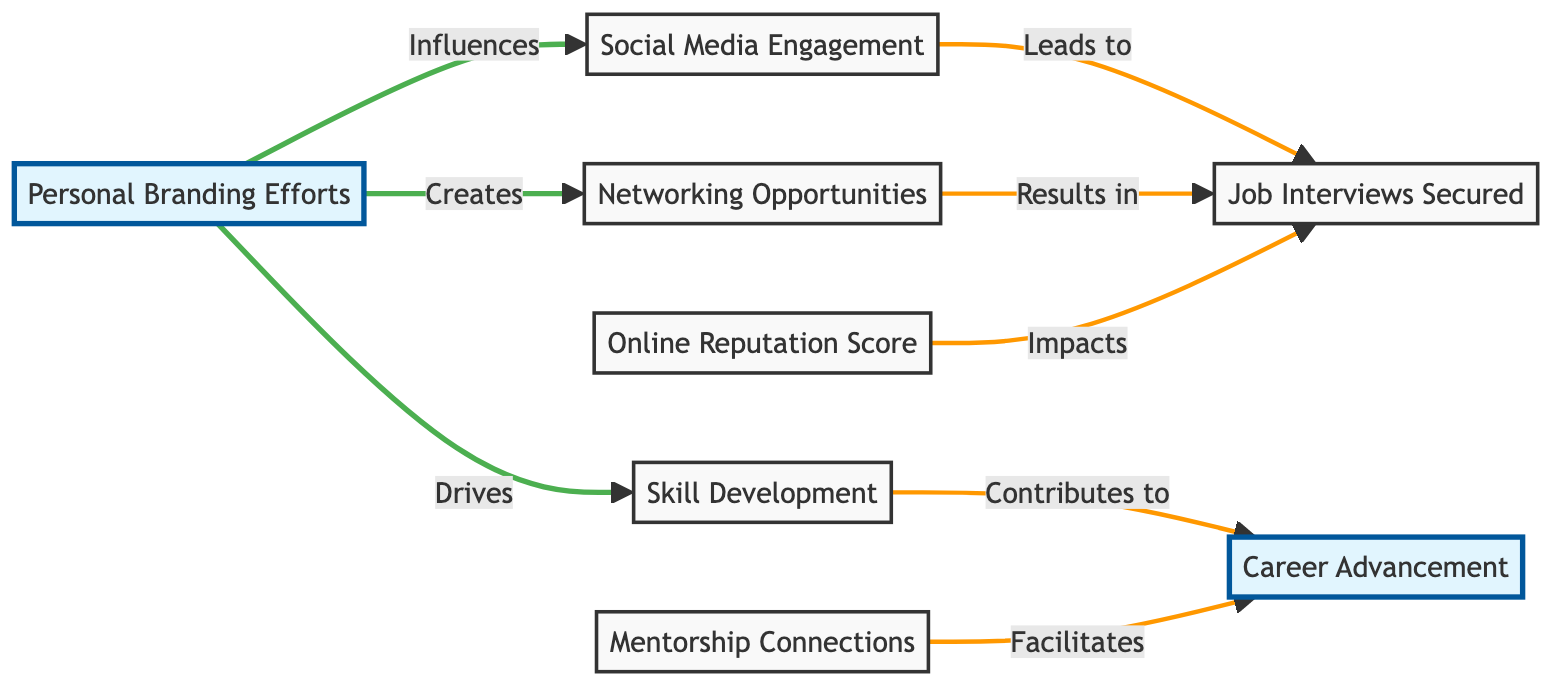What are the primary personal branding efforts in the diagram? The diagram identifies "Personal Branding Efforts" as the central node. From this node, three primary efforts emerge: "Social Media Engagement," "Networking Opportunities," and "Skill Development."
Answer: Social Media Engagement, Networking Opportunities, Skill Development How many nodes are there in total? By counting each unique entity in the diagram, we identify a total of eight nodes (including the central topic and sub-topics).
Answer: Eight Which node directly leads to Job Interviews? The diagram shows two edges leading into "Job Interviews Secured": one from "Social Media Engagement" and another from "Networking Opportunities." Both nodes have direct influences leading to job interviews.
Answer: Social Media Engagement, Networking Opportunities What impact does the "Online Reputation Score" have? In the diagram, "Online Reputation Score" has a directed edge that indicates it impacts "Job Interviews Secured." This means it relates positively to the number of secured job interviews.
Answer: Impacts Which metrics contribute to career advancement according to the diagram? The nodes leading to "Career Advancement" are "Skill Development" and "Mentorship Connections," indicating these metrics are essential in contributing to overall career growth.
Answer: Skill Development, Mentorship Connections Which personal branding effort influences the most metrics? "Personal Branding Efforts" is linked to three distinct metrics: "Social Media Engagement," "Networking Opportunities," and "Skill Development," making it the most influential node in the diagram.
Answer: Three What is the relationship between Skill Development and Career Advancement? "Skill Development" directly contributes to "Career Advancement," as indicated by a directed edge in the diagram. This establishes a clear relationship between enhancing skills and advancing in one's career.
Answer: Contributes How does "Social Media Engagement" lead to job interviews? In the diagram, "Social Media Engagement" has an edge that leads to "Job Interviews Secured," indicating that increased engagement on social media platforms is likely to secure more job interviews value.
Answer: Leads to 